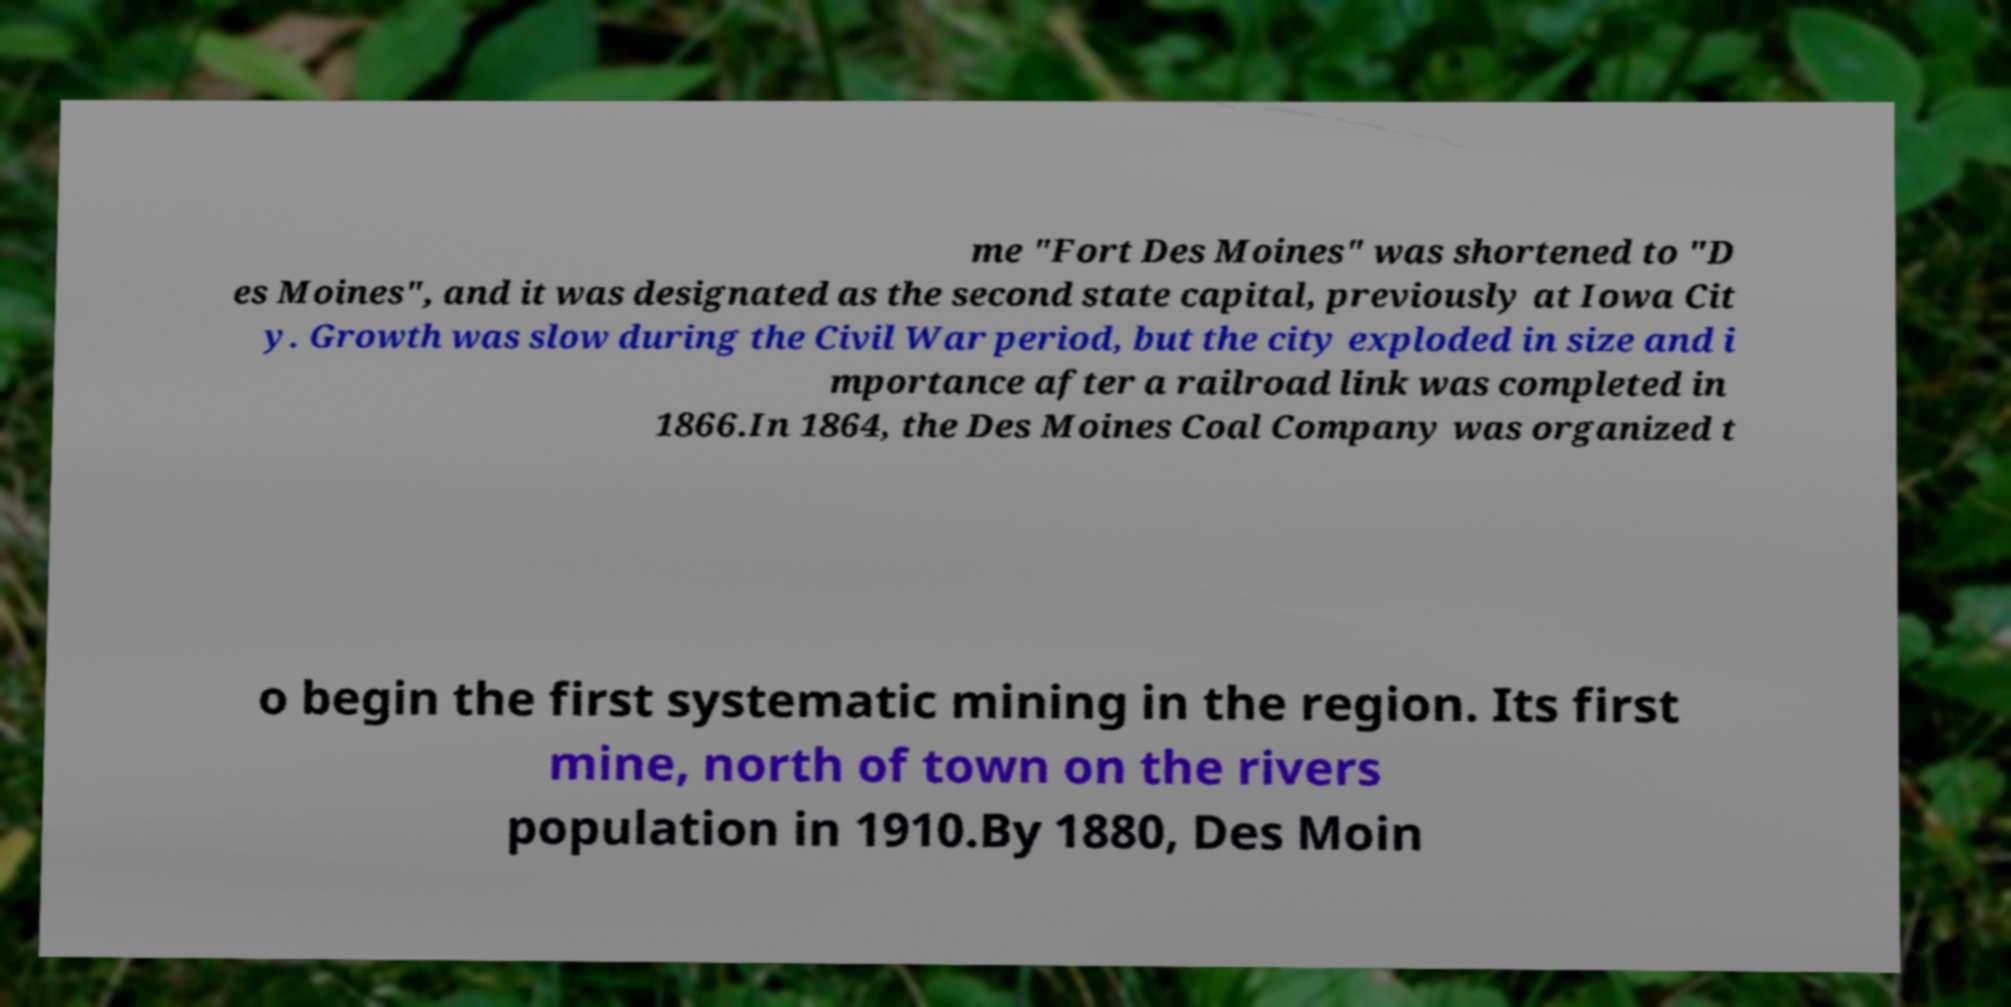I need the written content from this picture converted into text. Can you do that? me "Fort Des Moines" was shortened to "D es Moines", and it was designated as the second state capital, previously at Iowa Cit y. Growth was slow during the Civil War period, but the city exploded in size and i mportance after a railroad link was completed in 1866.In 1864, the Des Moines Coal Company was organized t o begin the first systematic mining in the region. Its first mine, north of town on the rivers population in 1910.By 1880, Des Moin 